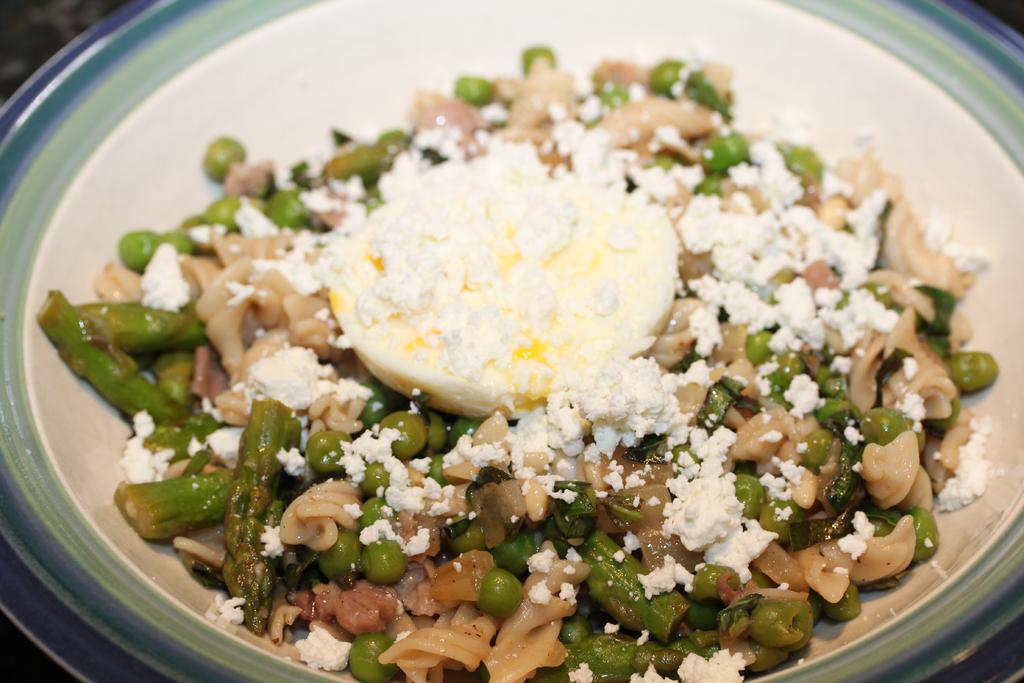What is on the plate in the image? There is food on a plate in the image. Can you see a snail jumping over the pail in the image? There is no pail or snail present in the image, and therefore no such activity can be observed. 